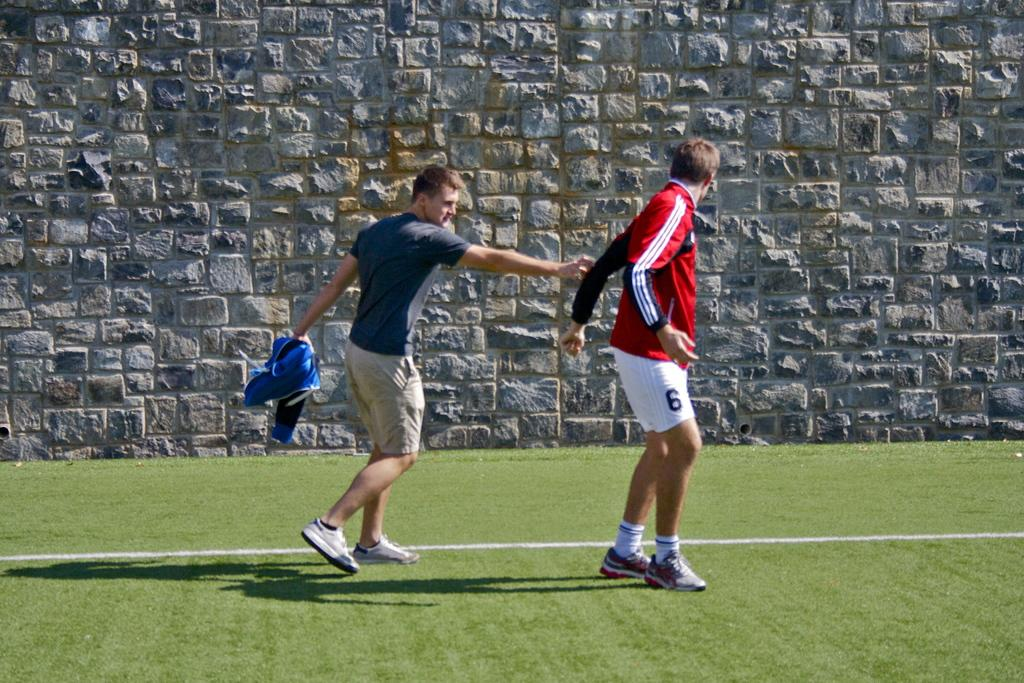How many people are in the image? There are two boys in the center of the image. What is the background of the image? The background of the image is grassland. What type of soup is being served to the fairies in the image? There are no fairies or soup present in the image. 